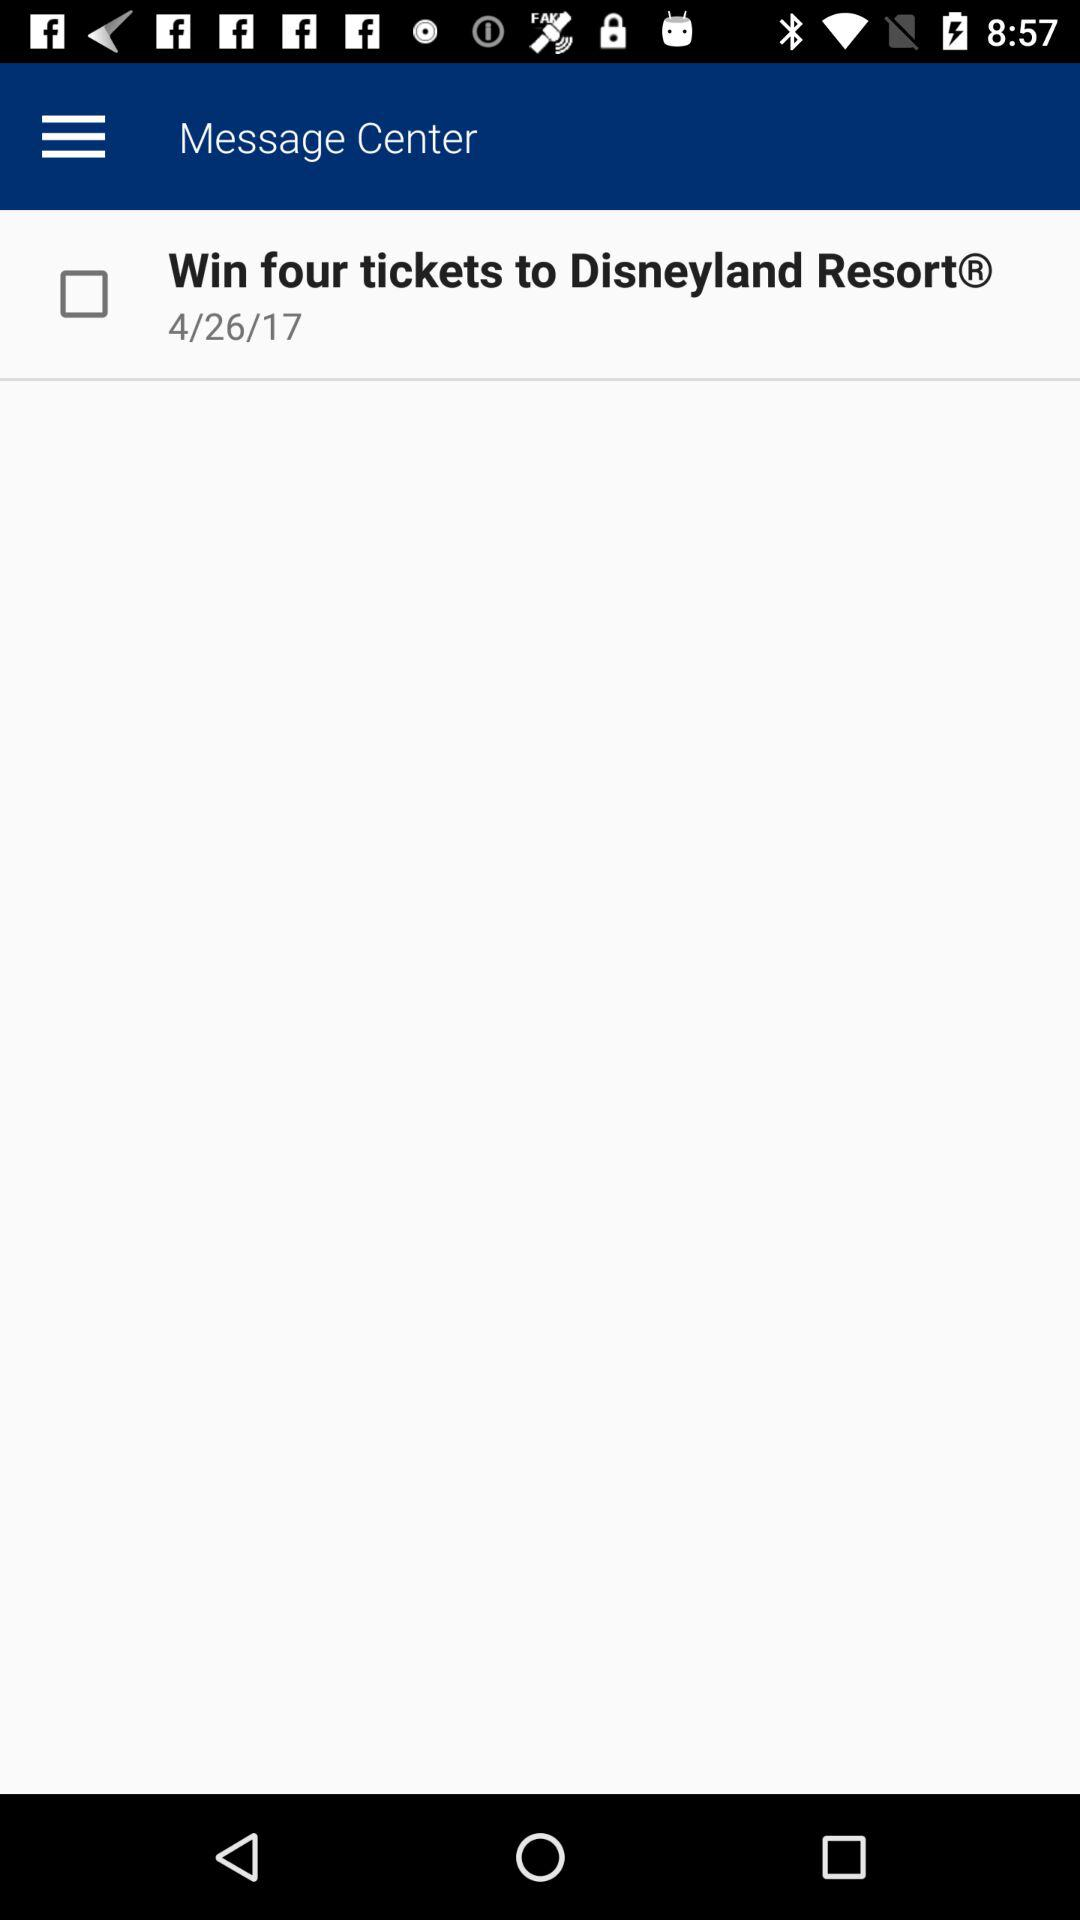What is the date? The date is April 26, 2017. 